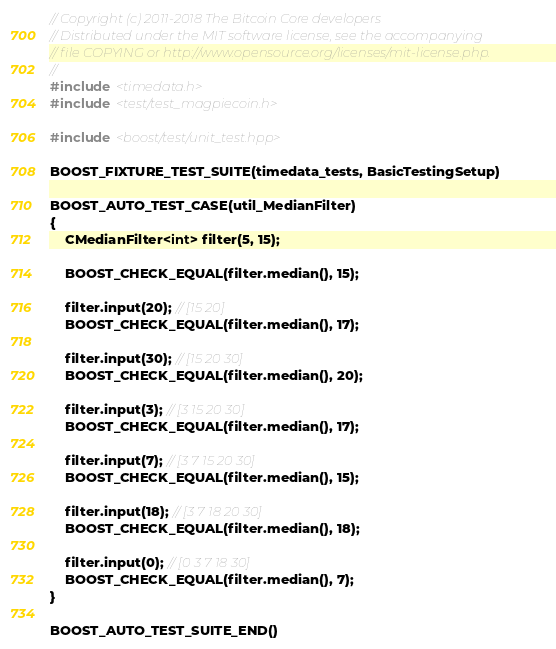Convert code to text. <code><loc_0><loc_0><loc_500><loc_500><_C++_>// Copyright (c) 2011-2018 The Bitcoin Core developers
// Distributed under the MIT software license, see the accompanying
// file COPYING or http://www.opensource.org/licenses/mit-license.php.
//
#include <timedata.h>
#include <test/test_magpiecoin.h>

#include <boost/test/unit_test.hpp>

BOOST_FIXTURE_TEST_SUITE(timedata_tests, BasicTestingSetup)

BOOST_AUTO_TEST_CASE(util_MedianFilter)
{
    CMedianFilter<int> filter(5, 15);

    BOOST_CHECK_EQUAL(filter.median(), 15);

    filter.input(20); // [15 20]
    BOOST_CHECK_EQUAL(filter.median(), 17);

    filter.input(30); // [15 20 30]
    BOOST_CHECK_EQUAL(filter.median(), 20);

    filter.input(3); // [3 15 20 30]
    BOOST_CHECK_EQUAL(filter.median(), 17);

    filter.input(7); // [3 7 15 20 30]
    BOOST_CHECK_EQUAL(filter.median(), 15);

    filter.input(18); // [3 7 18 20 30]
    BOOST_CHECK_EQUAL(filter.median(), 18);

    filter.input(0); // [0 3 7 18 30]
    BOOST_CHECK_EQUAL(filter.median(), 7);
}

BOOST_AUTO_TEST_SUITE_END()
</code> 